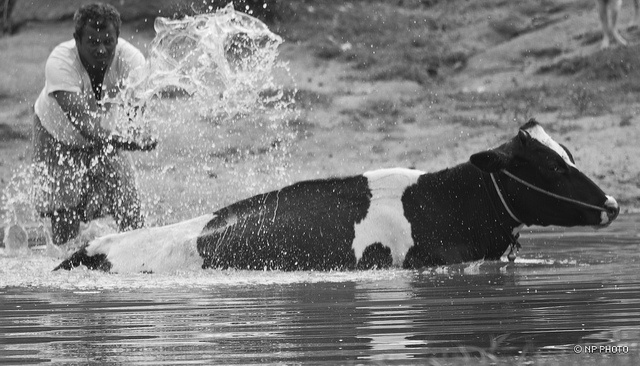Describe the objects in this image and their specific colors. I can see cow in black, lightgray, gray, and darkgray tones and people in black, gray, darkgray, and lightgray tones in this image. 